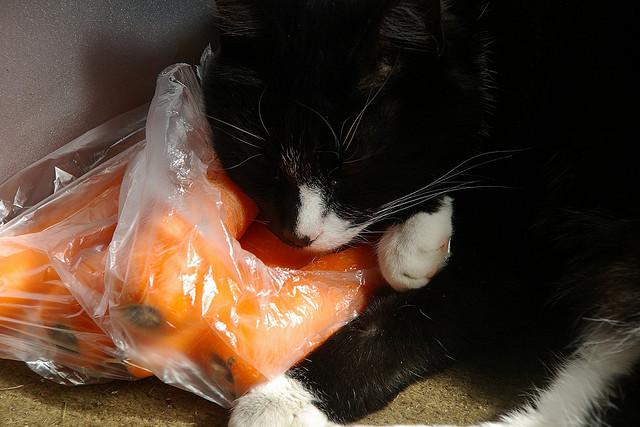Is this regular cat food?
Be succinct. No. Is the cat asleep?
Be succinct. Yes. Is the bag sealed?
Keep it brief. Yes. 